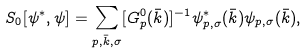<formula> <loc_0><loc_0><loc_500><loc_500>S _ { 0 } [ \psi ^ { * } , \psi ] = \sum _ { p , \bar { k } , \sigma } [ G ^ { 0 } _ { p } ( \bar { k } ) ] ^ { - 1 } \psi ^ { * } _ { p , \sigma } ( \bar { k } ) \psi _ { p , \sigma } ( \bar { k } ) ,</formula> 